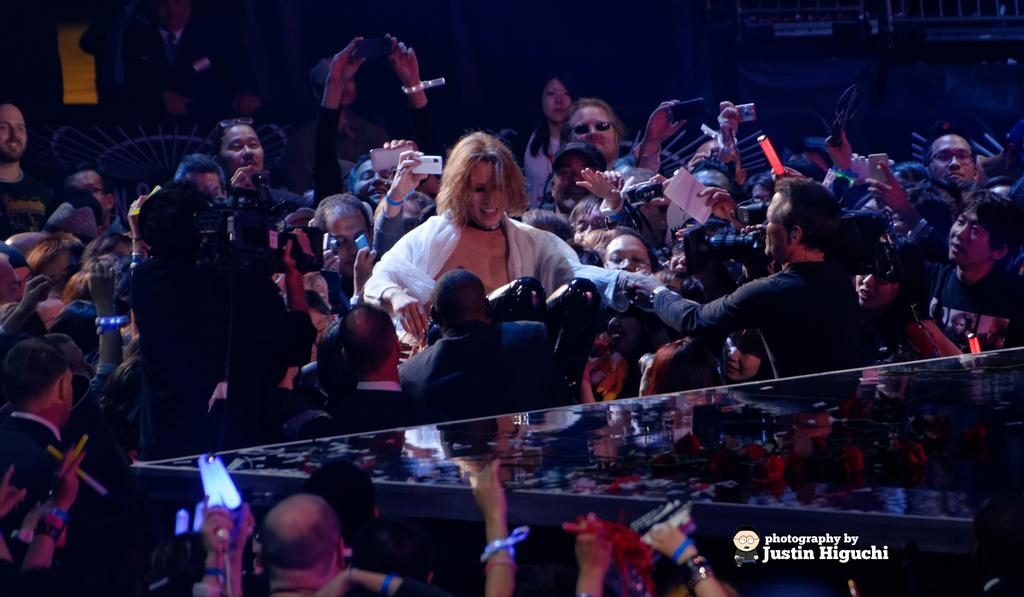What is the main feature in the center of the image? There is a stage in the center of the image. Can you describe the people in the image? There are people behind the stage. Is there any text visible in the image? Yes, there is some text at the bottom of the image. How does the son react to the earthquake in the image? There is no son or earthquake present in the image. 